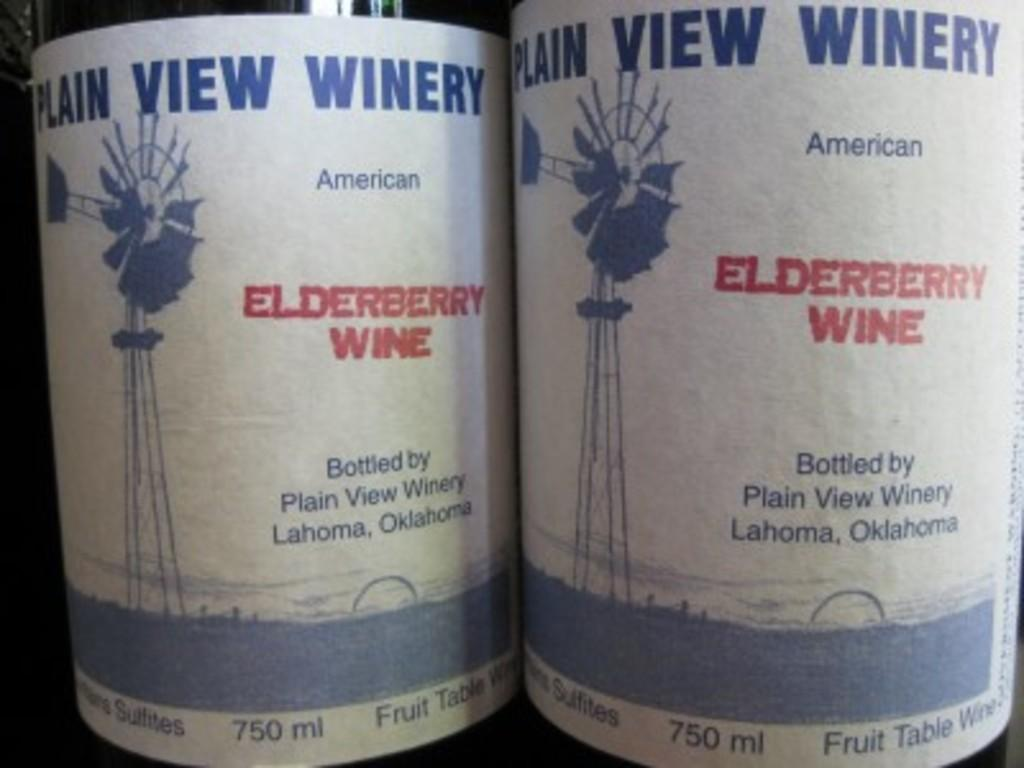<image>
Relay a brief, clear account of the picture shown. Two bottles of Plain View Winery's Elderberry Wine. 